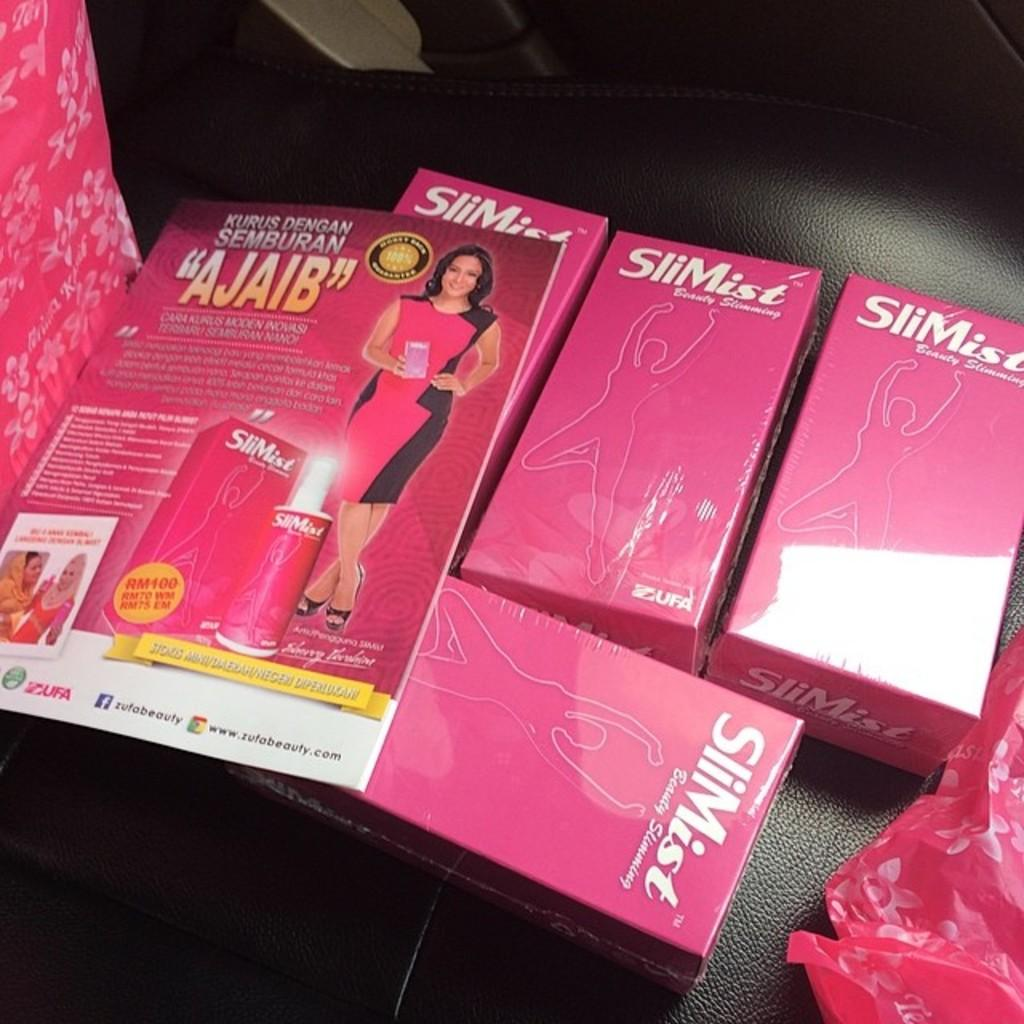What objects can be seen in the image? There are boxes, a magazine, and covers in the image. Where might this image have been taken? The image appears to be taken inside a car. What color are the writer's eyes in the image? There is no writer present in the image, so it is not possible to determine the color of their eyes. 